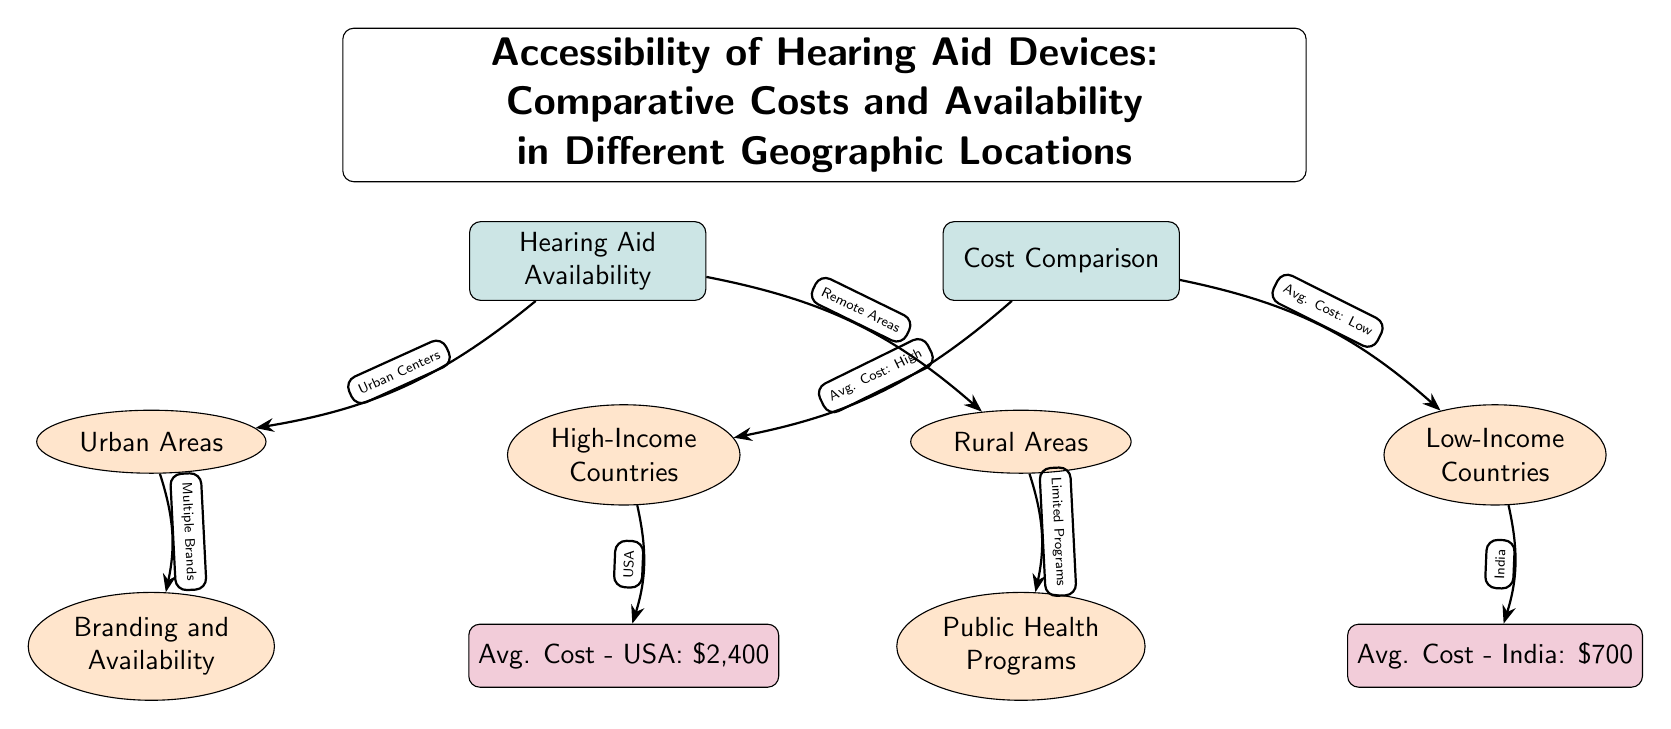What are the two main categories under Hearing Aid Availability? The diagram shows two main categories, which are Urban Areas and Rural Areas, represented as sub nodes under Hearing Aid Availability.
Answer: Urban Areas and Rural Areas What is the average cost of hearing aids in the USA? The diagram lists the average cost in the USA as $2,400 under the High-Income Countries node, showing the cost comparison related to availability.
Answer: $2,400 What are the public health initiatives mentioned for Rural Areas? The diagram indicates that Limited Programs are associated with Rural Areas, suggesting fewer health initiatives or resources compared to Urban Areas.
Answer: Limited Programs How does the average cost of hearing aids in low-income countries compare? The diagram illustrates that the average cost in India, categorized under Low-Income Countries, is $700 which is notably lower than the $2,400 in the USA. Thus, it highlights the disparity in costs between these geographic categories.
Answer: $700 Which areas have multiple brands of hearing aids available according to the diagram? The diagram indicates that Urban Areas, as a sub node, are associated with Branding and Availability, which implies a greater variety of hearing aid brands available in these locations.
Answer: Urban Areas How many main nodes are in the diagram? The diagram features two main nodes, Hearing Aid Availability and Cost Comparison, indicating the primary focus areas of the diagram.
Answer: 2 What does the arrow from High-Income Countries point to? The arrow from High-Income Countries points to the Avg. Cost - USA node, showing the specific data related to costs in a specific country under this category.
Answer: Avg. Cost - USA What type of hearing aid resources are indicated in Urban Areas? The diagram illustrates Branding and Availability, suggesting that Urban Areas have access to a variety of brands and resources, making hearing aids more accessible compared to Rural Areas.
Answer: Branding and Availability What does the diagram suggest about hearing aid availability in Rural Areas? The diagram suggests that Rural Areas face challenges such as Limited Programs, indicating fewer resources and availability compared to Urban Areas where multiple brands exist.
Answer: Limited Programs 